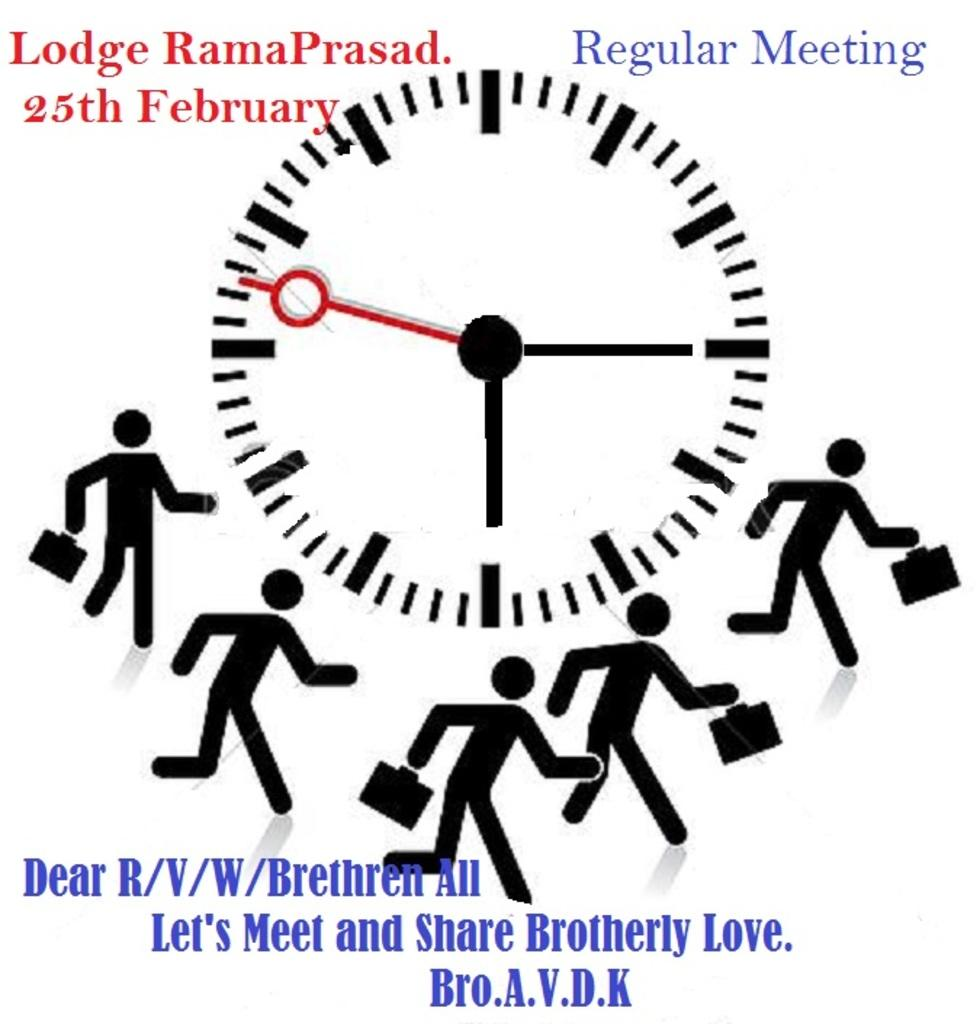Provide a one-sentence caption for the provided image. A clock in the center of a page with stick figures running around it acts as a reminder for a Regular Meeting. 